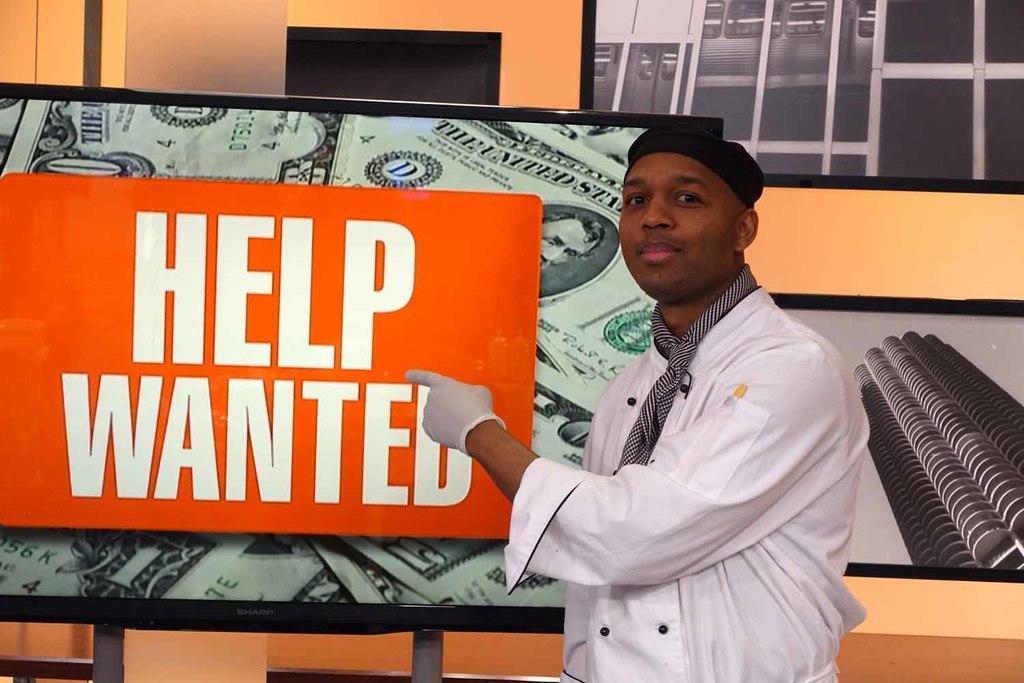How would you summarize this image in a sentence or two? In this picture I can see a person. I can see the screens. 